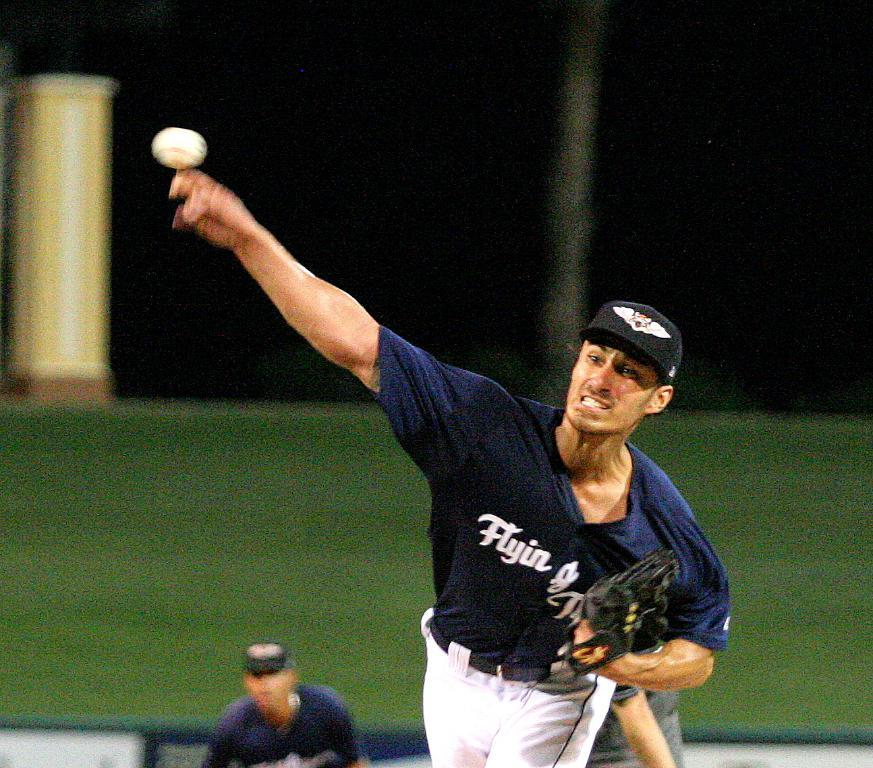Provide a one-sentence caption for the provided image. A baseball player catches the ball in a jersey labeled "Flying.". 